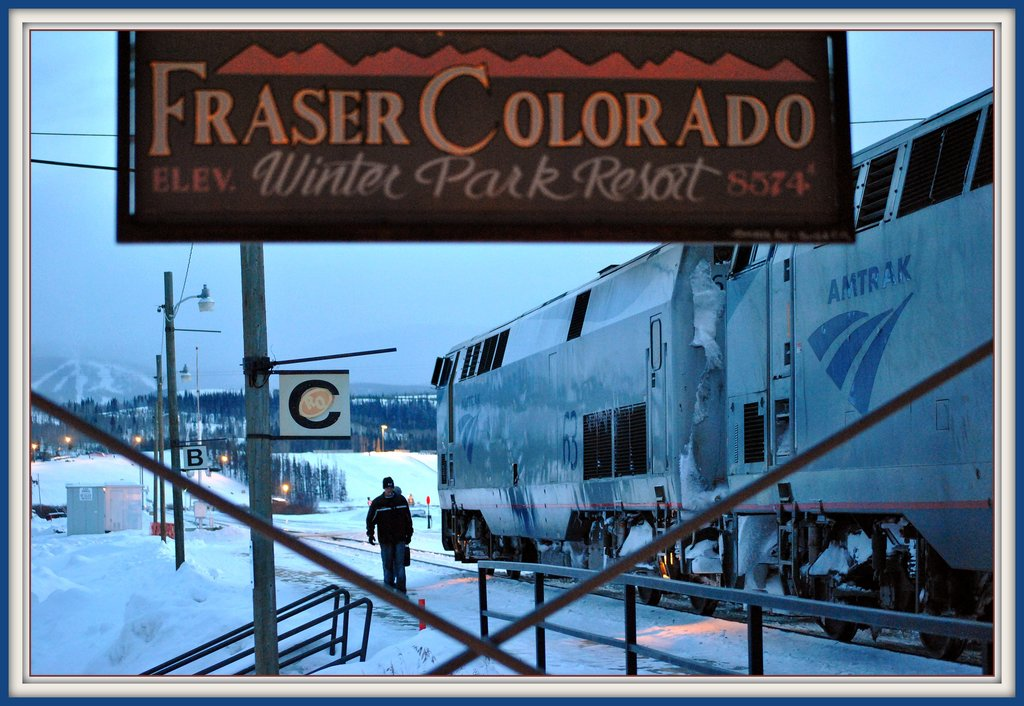Can you describe the atmosphere suggested by the lighting and the scenery in this image? The image portrays a serene and possibly early morning or dusk atmosphere, emphasized by the soft blue and cold tones that envelop the station. The lighting is subtle, with the train and station lightly illuminated, which contrasts with the twilight engulfing the surrounding snowy landscape. This setting suggests a quiet, almost contemplative moment before the day's bustle or as it winds down. 